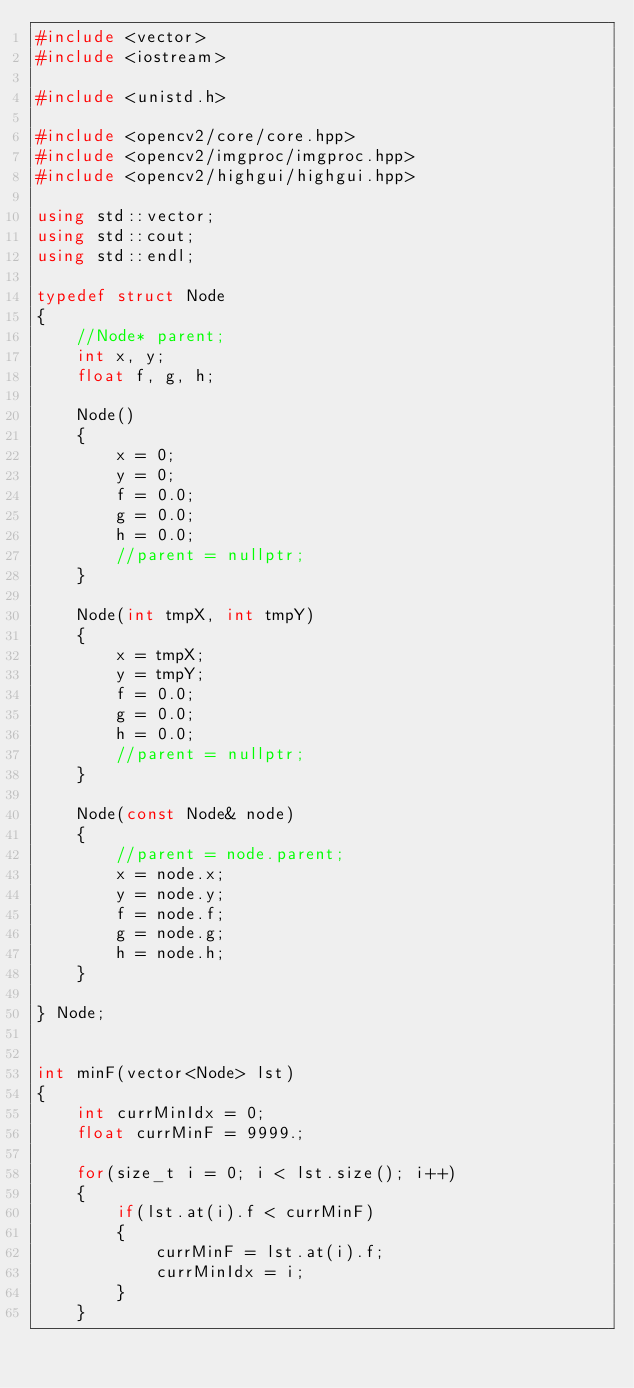Convert code to text. <code><loc_0><loc_0><loc_500><loc_500><_C++_>#include <vector>
#include <iostream>

#include <unistd.h>

#include <opencv2/core/core.hpp>
#include <opencv2/imgproc/imgproc.hpp>
#include <opencv2/highgui/highgui.hpp>

using std::vector;
using std::cout;
using std::endl;

typedef struct Node
{
    //Node* parent;
    int x, y;
    float f, g, h;
    
    Node()
    {
        x = 0;
        y = 0;
        f = 0.0;
        g = 0.0;
        h = 0.0;
        //parent = nullptr;
    }
    
    Node(int tmpX, int tmpY)
    {
        x = tmpX;
        y = tmpY;
        f = 0.0;
        g = 0.0;
        h = 0.0;
        //parent = nullptr;
    }
    
    Node(const Node& node)
    {
        //parent = node.parent;
        x = node.x;
        y = node.y;
        f = node.f;
        g = node.g;
        h = node.h;
    }
    
} Node;


int minF(vector<Node> lst)
{
    int currMinIdx = 0;
    float currMinF = 9999.;

    for(size_t i = 0; i < lst.size(); i++)
    {
        if(lst.at(i).f < currMinF)
        {
            currMinF = lst.at(i).f;
            currMinIdx = i;
        }
    }
    </code> 